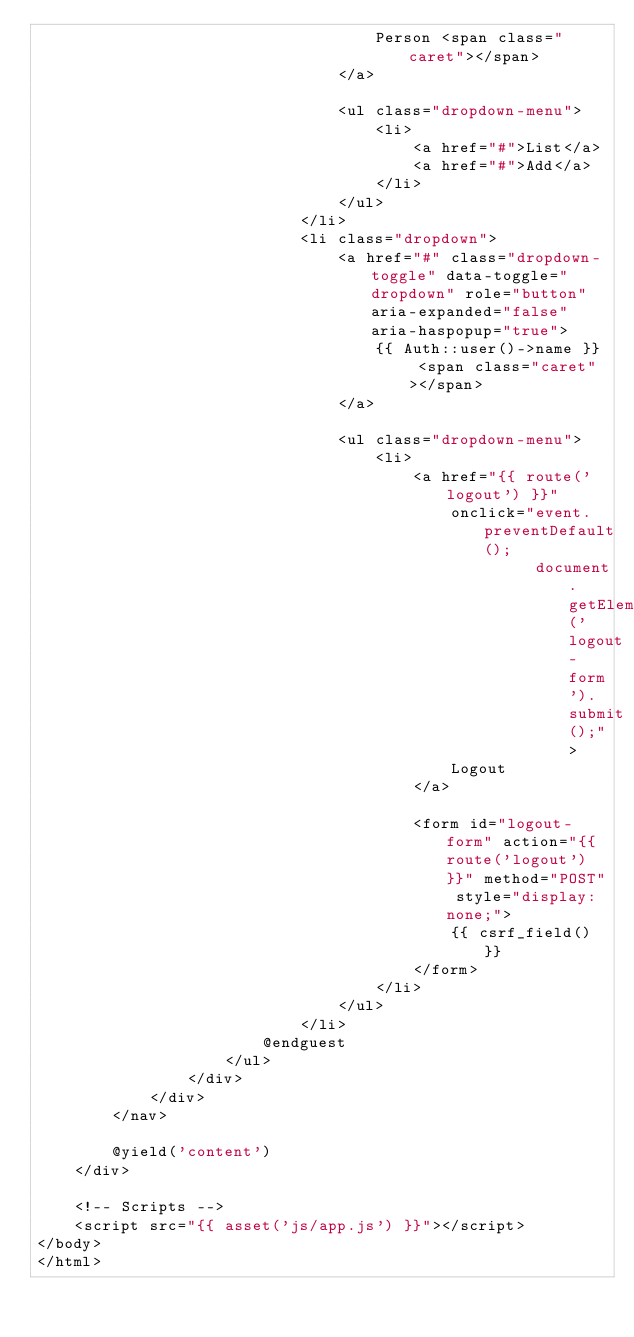<code> <loc_0><loc_0><loc_500><loc_500><_PHP_>                                    Person <span class="caret"></span>
                                </a>

                                <ul class="dropdown-menu">
                                    <li>
                                        <a href="#">List</a>
                                        <a href="#">Add</a>
                                    </li>
                                </ul>
                            </li>
                            <li class="dropdown">
                                <a href="#" class="dropdown-toggle" data-toggle="dropdown" role="button" aria-expanded="false" aria-haspopup="true">
                                    {{ Auth::user()->name }} <span class="caret"></span>
                                </a>

                                <ul class="dropdown-menu">
                                    <li>
                                        <a href="{{ route('logout') }}"
                                            onclick="event.preventDefault();
                                                     document.getElementById('logout-form').submit();">
                                            Logout
                                        </a>

                                        <form id="logout-form" action="{{ route('logout') }}" method="POST" style="display: none;">
                                            {{ csrf_field() }}
                                        </form>
                                    </li>
                                </ul>
                            </li>
                        @endguest
                    </ul>
                </div>
            </div>
        </nav>

        @yield('content')
    </div>

    <!-- Scripts -->
    <script src="{{ asset('js/app.js') }}"></script>
</body>
</html>
</code> 